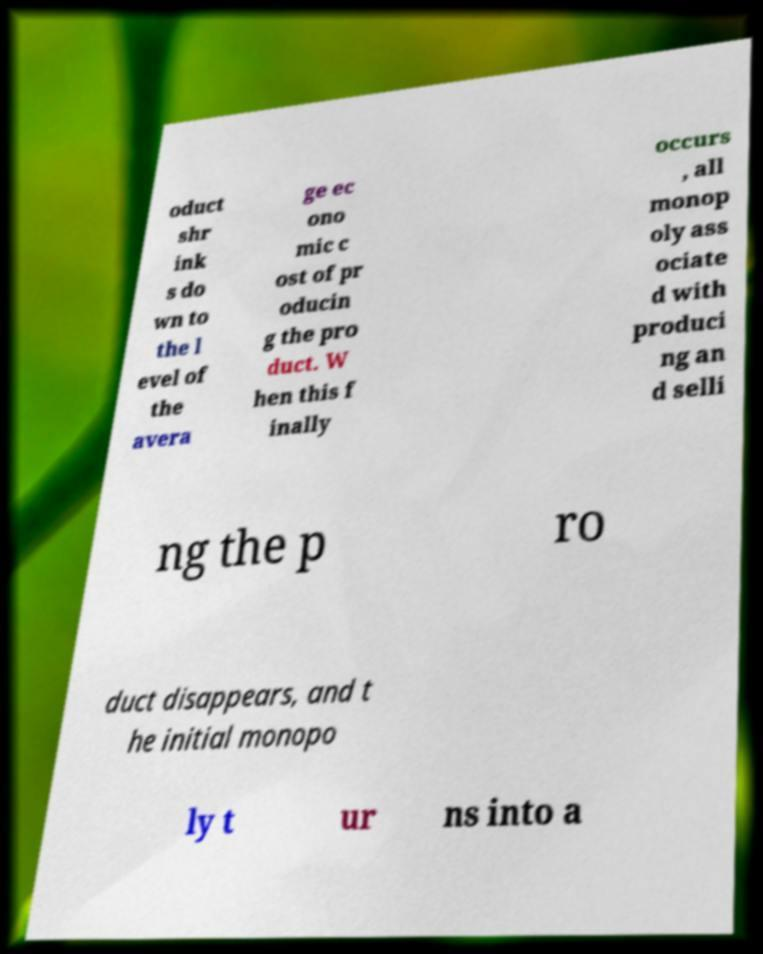Please identify and transcribe the text found in this image. oduct shr ink s do wn to the l evel of the avera ge ec ono mic c ost of pr oducin g the pro duct. W hen this f inally occurs , all monop oly ass ociate d with produci ng an d selli ng the p ro duct disappears, and t he initial monopo ly t ur ns into a 